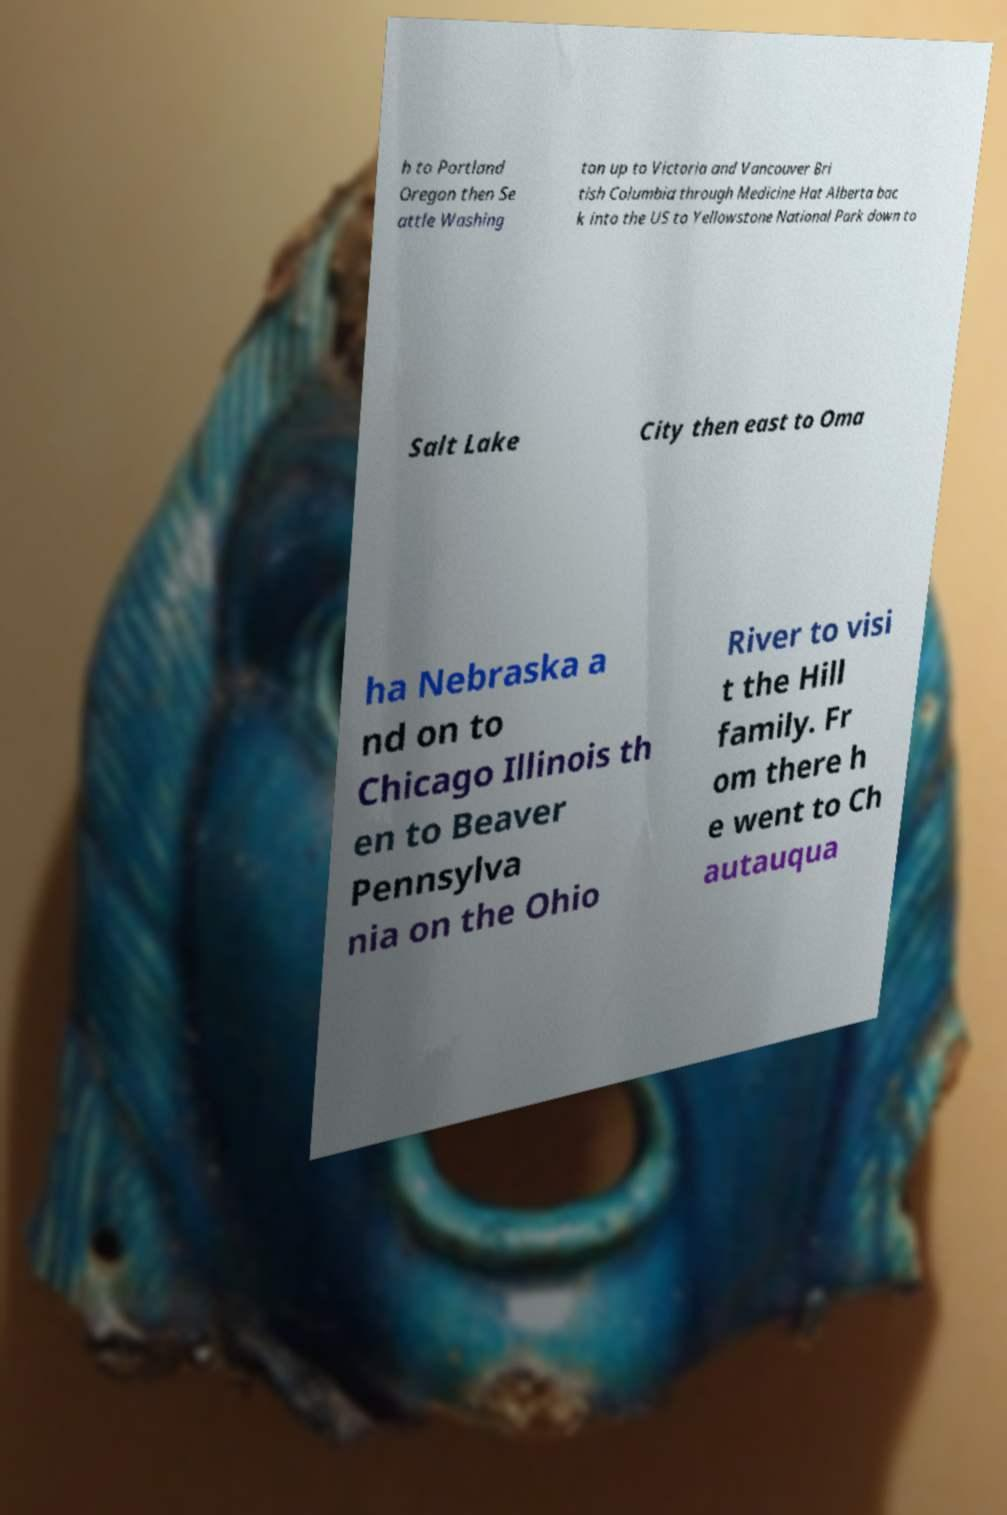Could you extract and type out the text from this image? h to Portland Oregon then Se attle Washing ton up to Victoria and Vancouver Bri tish Columbia through Medicine Hat Alberta bac k into the US to Yellowstone National Park down to Salt Lake City then east to Oma ha Nebraska a nd on to Chicago Illinois th en to Beaver Pennsylva nia on the Ohio River to visi t the Hill family. Fr om there h e went to Ch autauqua 